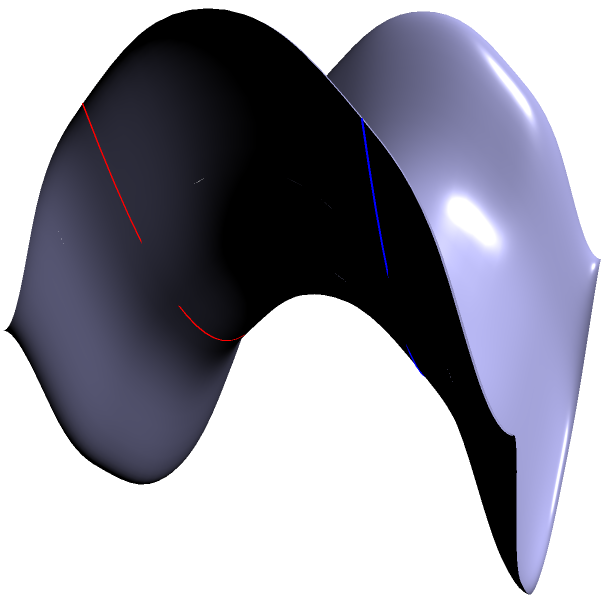In the context of a co-op challenge stream, you're presented with a saddle-shaped surface. Two seemingly parallel lines are drawn on this surface, as shown in the image. How would you explain to your partner and the audience why these lines, despite starting parallel, appear to diverge? Let's break this down step-by-step, as if we're explaining it to our co-op partner and stream audience:

1. First, we need to understand that this surface is called a hyperbolic paraboloid, or a "saddle" surface. Its shape is described by the equation $z = x^2 - y^2$.

2. In Euclidean geometry (on a flat plane), parallel lines maintain a constant distance from each other and never intersect. However, this surface is non-Euclidean.

3. The red and blue lines on the surface are what we call "geodesics". In non-Euclidean geometry, geodesics are the equivalent of straight lines - they represent the shortest path between two points on the surface.

4. These geodesics start parallel at $x = 0$, but as we move along the x-axis, they begin to diverge. This is because the surface is curving differently in different directions.

5. Mathematically, we can understand this by looking at the surface's curvature. The Gaussian curvature at any point on this surface is given by:

   $K = \frac{-4}{(1+4x^2+4y^2)^2}$

6. This negative curvature is what causes the geodesics to diverge. In areas of negative curvature, parallel lines tend to move apart from each other.

7. It's like if you and your co-op partner started walking "straight" on this saddle surface - you'd find yourselves getting further apart, even though you're both walking "straight"!

This phenomenon illustrates a fundamental principle of non-Euclidean geometry: the behavior of "straight" lines (geodesics) depends on the curvature of the space they're in.
Answer: Negative curvature of the saddle surface causes geodesics to diverge. 